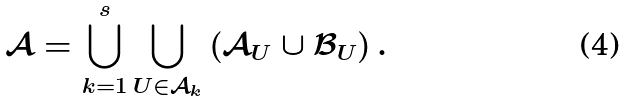<formula> <loc_0><loc_0><loc_500><loc_500>\mathcal { A } = \bigcup _ { k = 1 } ^ { s } \bigcup _ { U \in \mathcal { A } _ { k } } \left ( \mathcal { A } _ { U } \cup \mathcal { B } _ { U } \right ) .</formula> 